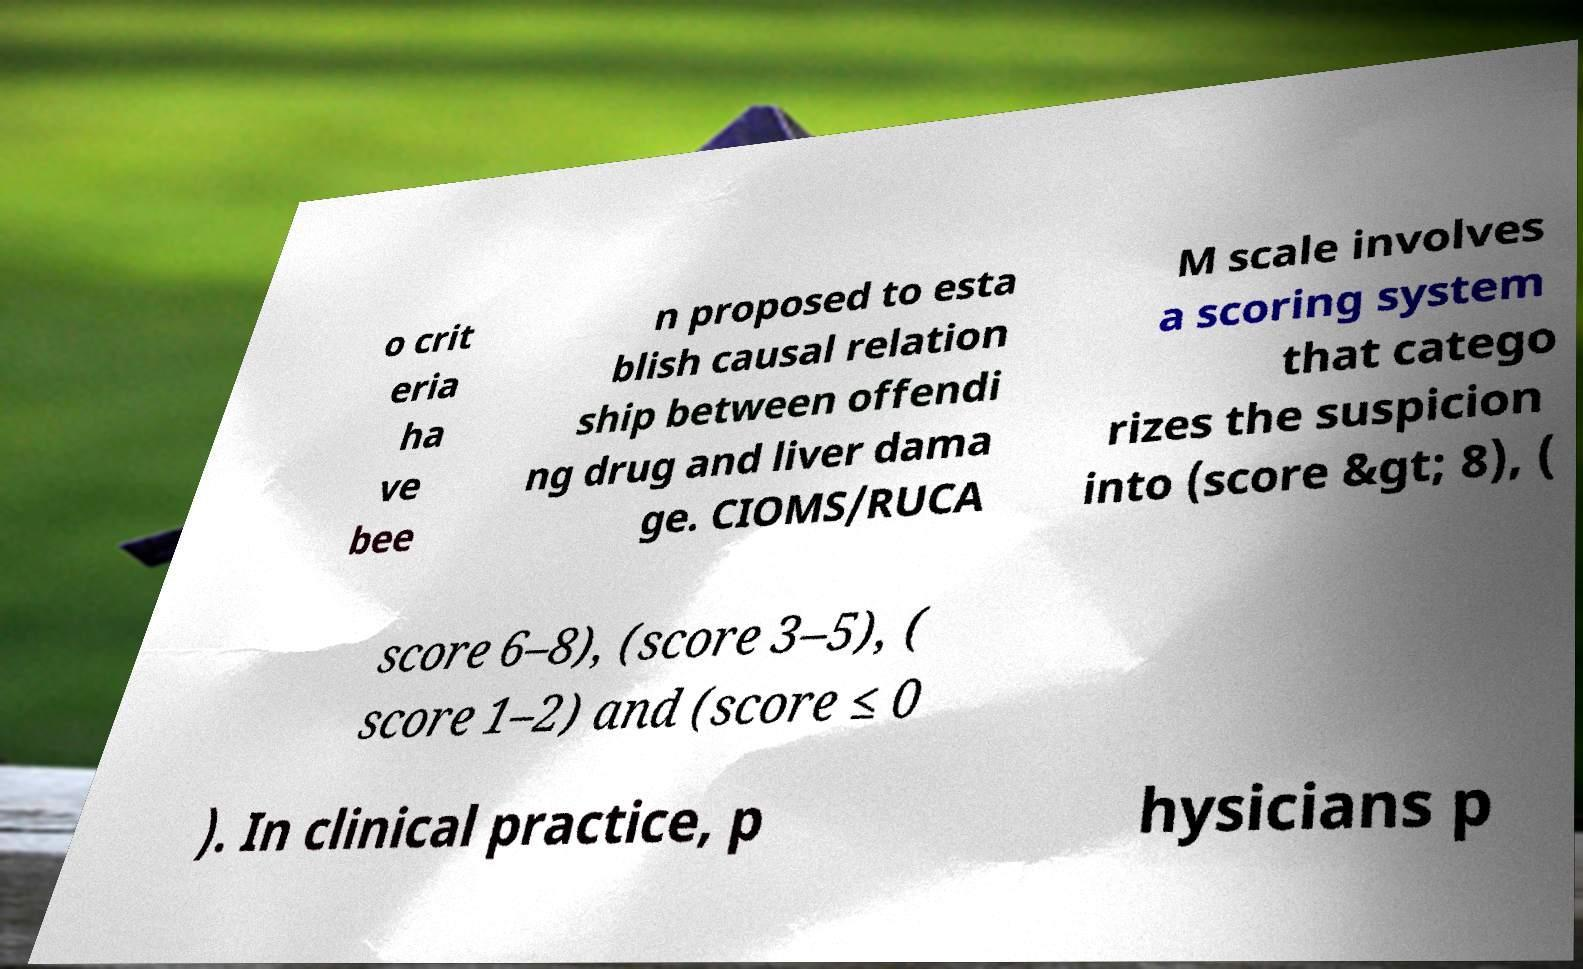Could you extract and type out the text from this image? o crit eria ha ve bee n proposed to esta blish causal relation ship between offendi ng drug and liver dama ge. CIOMS/RUCA M scale involves a scoring system that catego rizes the suspicion into (score &gt; 8), ( score 6–8), (score 3–5), ( score 1–2) and (score ≤ 0 ). In clinical practice, p hysicians p 